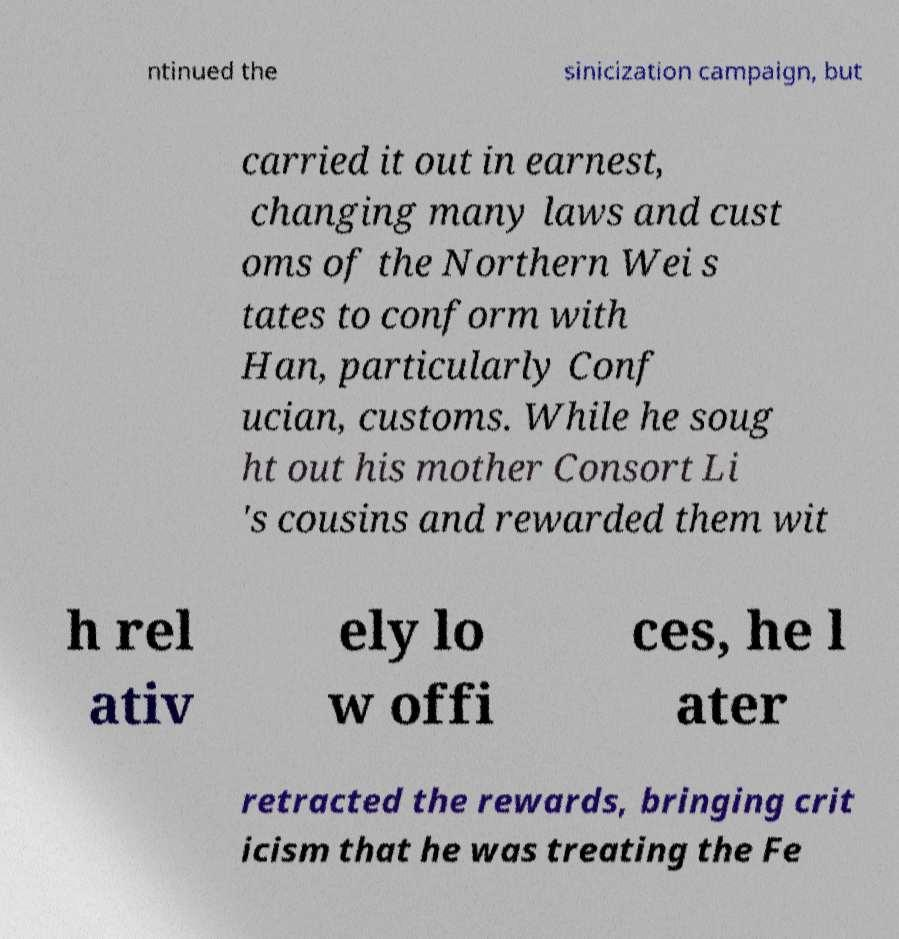There's text embedded in this image that I need extracted. Can you transcribe it verbatim? ntinued the sinicization campaign, but carried it out in earnest, changing many laws and cust oms of the Northern Wei s tates to conform with Han, particularly Conf ucian, customs. While he soug ht out his mother Consort Li 's cousins and rewarded them wit h rel ativ ely lo w offi ces, he l ater retracted the rewards, bringing crit icism that he was treating the Fe 